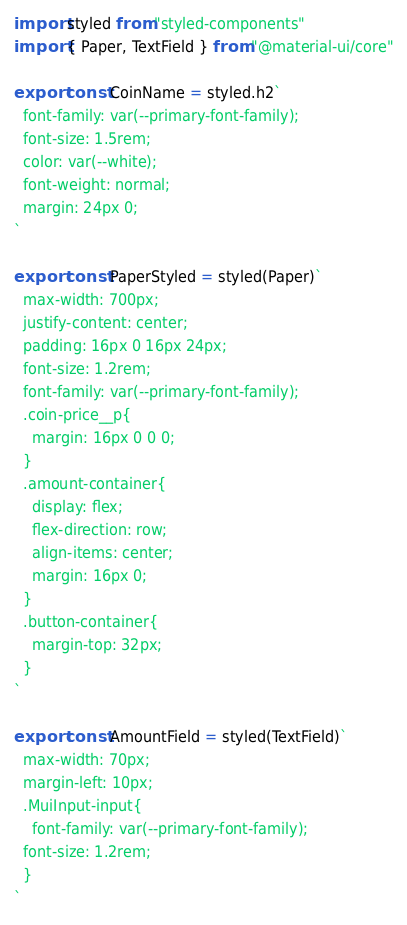<code> <loc_0><loc_0><loc_500><loc_500><_JavaScript_>import styled from "styled-components"
import { Paper, TextField } from "@material-ui/core"

export const CoinName = styled.h2`
  font-family: var(--primary-font-family);
  font-size: 1.5rem;
  color: var(--white);
  font-weight: normal;
  margin: 24px 0;
`

export const PaperStyled = styled(Paper)`
  max-width: 700px;
  justify-content: center;
  padding: 16px 0 16px 24px;
  font-size: 1.2rem;
  font-family: var(--primary-font-family);
  .coin-price__p{
    margin: 16px 0 0 0;
  }
  .amount-container{
    display: flex;
    flex-direction: row;
    align-items: center;
    margin: 16px 0;
  }
  .button-container{
    margin-top: 32px;
  }
`

export const AmountField = styled(TextField)`
  max-width: 70px;
  margin-left: 10px;
  .MuiInput-input{
    font-family: var(--primary-font-family);
  font-size: 1.2rem;
  }
`</code> 